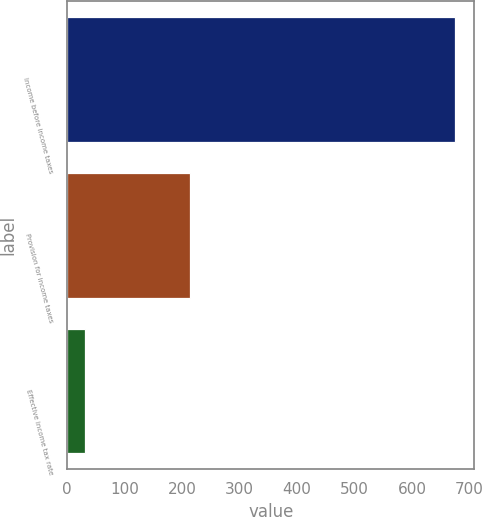Convert chart to OTSL. <chart><loc_0><loc_0><loc_500><loc_500><bar_chart><fcel>Income before income taxes<fcel>Provision for income taxes<fcel>Effective income tax rate<nl><fcel>674.8<fcel>213.3<fcel>31.6<nl></chart> 